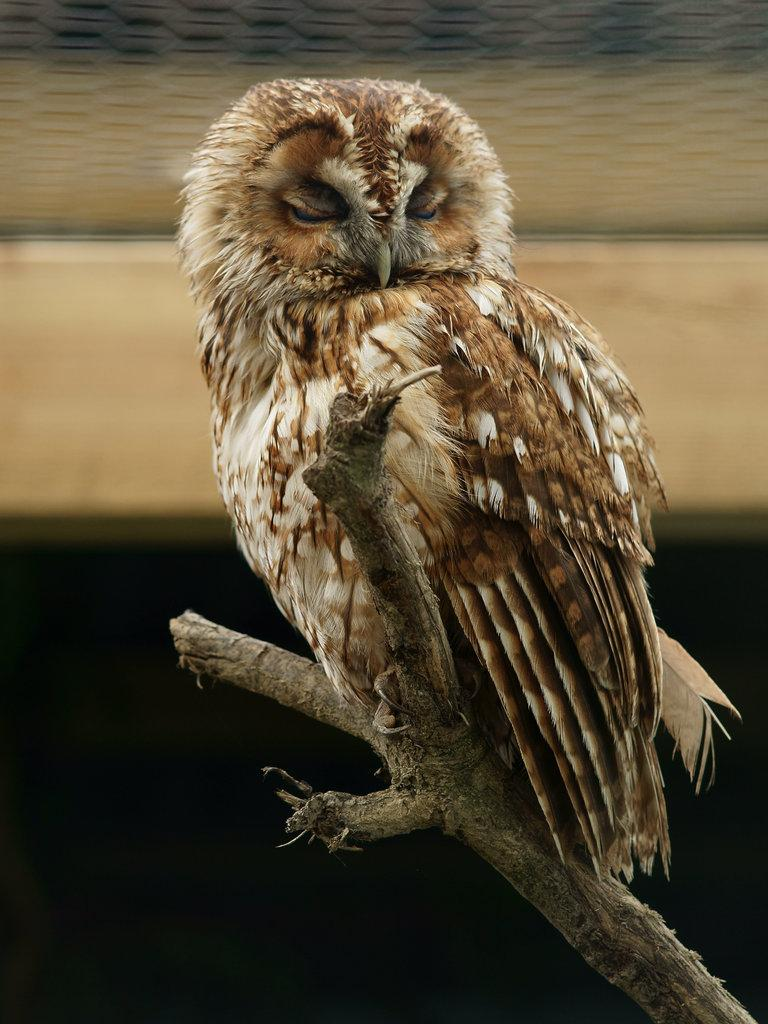What animal is the main subject of the image? There is an owl in the image. Where is the owl located in the image? The owl is on a stem. Can you describe the background of the image? The background of the image is blurred. What type of kettle can be seen in the image? A: There is no kettle present in the image; it features an owl on a stem with a blurred background. How many cattle are visible in the image? There are no cattle visible in the image; it features an owl on a stem with a blurred background. 